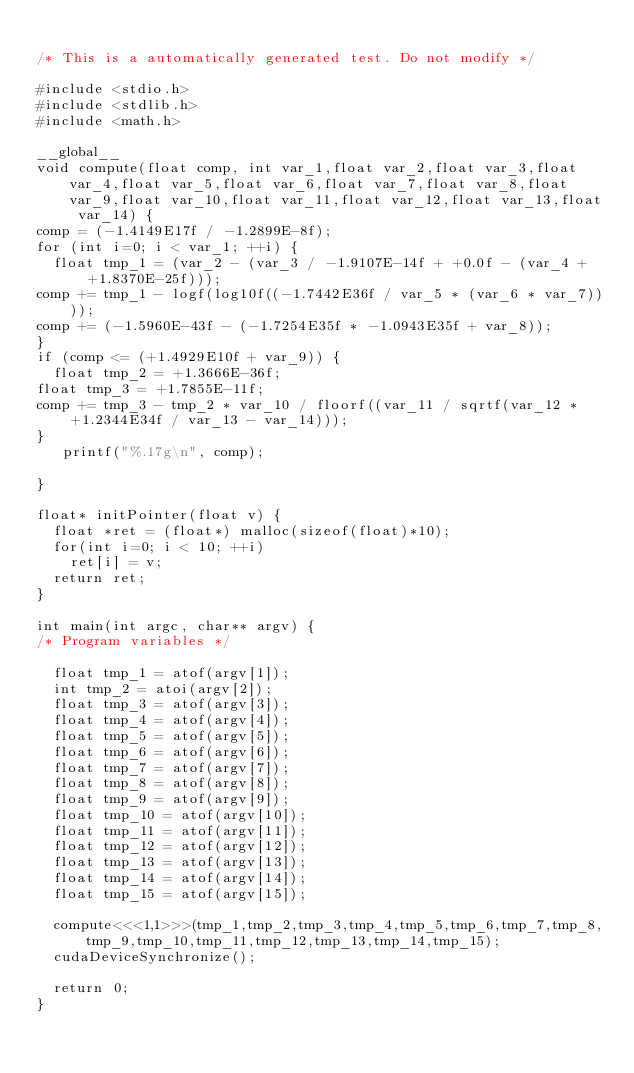<code> <loc_0><loc_0><loc_500><loc_500><_Cuda_>
/* This is a automatically generated test. Do not modify */

#include <stdio.h>
#include <stdlib.h>
#include <math.h>

__global__
void compute(float comp, int var_1,float var_2,float var_3,float var_4,float var_5,float var_6,float var_7,float var_8,float var_9,float var_10,float var_11,float var_12,float var_13,float var_14) {
comp = (-1.4149E17f / -1.2899E-8f);
for (int i=0; i < var_1; ++i) {
  float tmp_1 = (var_2 - (var_3 / -1.9107E-14f + +0.0f - (var_4 + +1.8370E-25f)));
comp += tmp_1 - logf(log10f((-1.7442E36f / var_5 * (var_6 * var_7))));
comp += (-1.5960E-43f - (-1.7254E35f * -1.0943E35f + var_8));
}
if (comp <= (+1.4929E10f + var_9)) {
  float tmp_2 = +1.3666E-36f;
float tmp_3 = +1.7855E-11f;
comp += tmp_3 - tmp_2 * var_10 / floorf((var_11 / sqrtf(var_12 * +1.2344E34f / var_13 - var_14)));
}
   printf("%.17g\n", comp);

}

float* initPointer(float v) {
  float *ret = (float*) malloc(sizeof(float)*10);
  for(int i=0; i < 10; ++i)
    ret[i] = v;
  return ret;
}

int main(int argc, char** argv) {
/* Program variables */

  float tmp_1 = atof(argv[1]);
  int tmp_2 = atoi(argv[2]);
  float tmp_3 = atof(argv[3]);
  float tmp_4 = atof(argv[4]);
  float tmp_5 = atof(argv[5]);
  float tmp_6 = atof(argv[6]);
  float tmp_7 = atof(argv[7]);
  float tmp_8 = atof(argv[8]);
  float tmp_9 = atof(argv[9]);
  float tmp_10 = atof(argv[10]);
  float tmp_11 = atof(argv[11]);
  float tmp_12 = atof(argv[12]);
  float tmp_13 = atof(argv[13]);
  float tmp_14 = atof(argv[14]);
  float tmp_15 = atof(argv[15]);

  compute<<<1,1>>>(tmp_1,tmp_2,tmp_3,tmp_4,tmp_5,tmp_6,tmp_7,tmp_8,tmp_9,tmp_10,tmp_11,tmp_12,tmp_13,tmp_14,tmp_15);
  cudaDeviceSynchronize();

  return 0;
}
</code> 